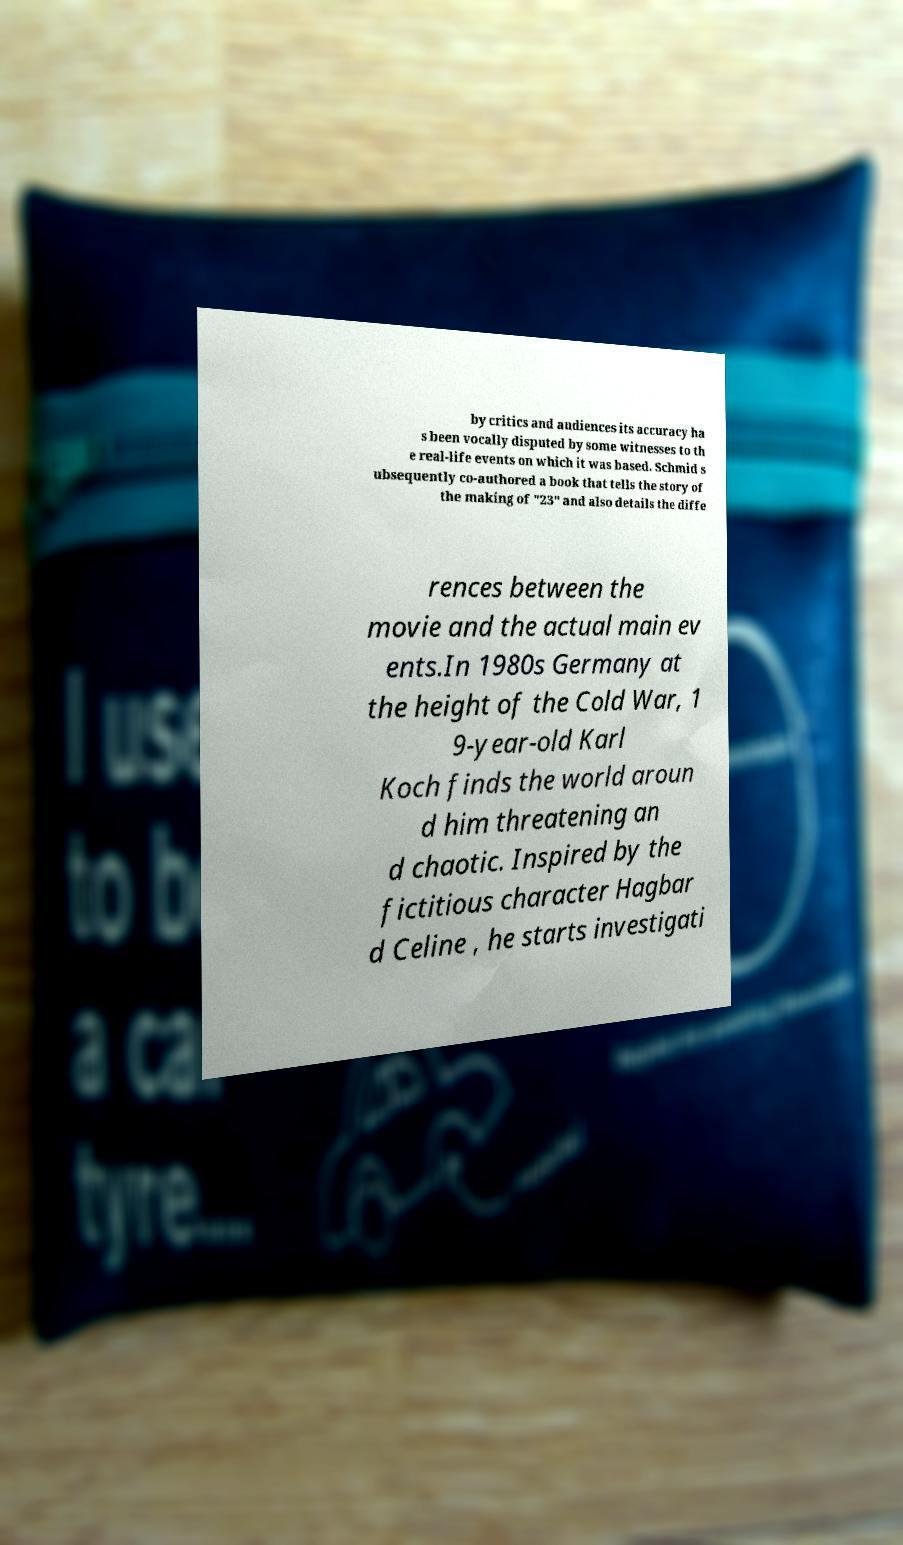There's text embedded in this image that I need extracted. Can you transcribe it verbatim? by critics and audiences its accuracy ha s been vocally disputed by some witnesses to th e real-life events on which it was based. Schmid s ubsequently co-authored a book that tells the story of the making of "23" and also details the diffe rences between the movie and the actual main ev ents.In 1980s Germany at the height of the Cold War, 1 9-year-old Karl Koch finds the world aroun d him threatening an d chaotic. Inspired by the fictitious character Hagbar d Celine , he starts investigati 